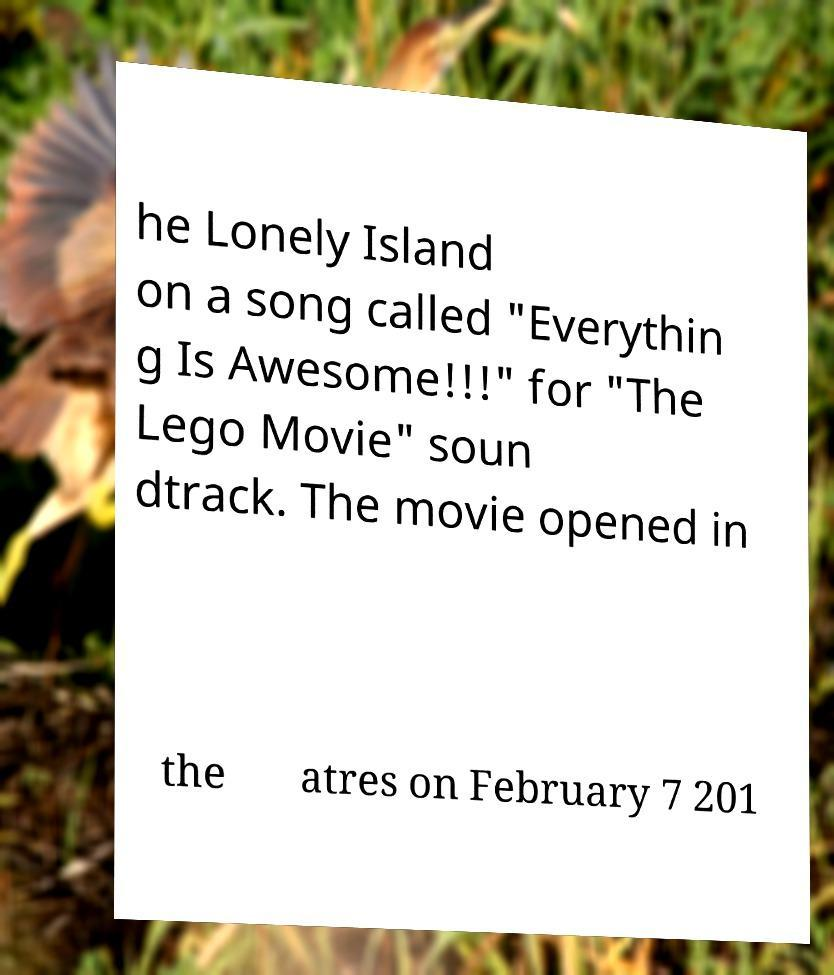Could you assist in decoding the text presented in this image and type it out clearly? he Lonely Island on a song called "Everythin g Is Awesome!!!" for "The Lego Movie" soun dtrack. The movie opened in the atres on February 7 201 